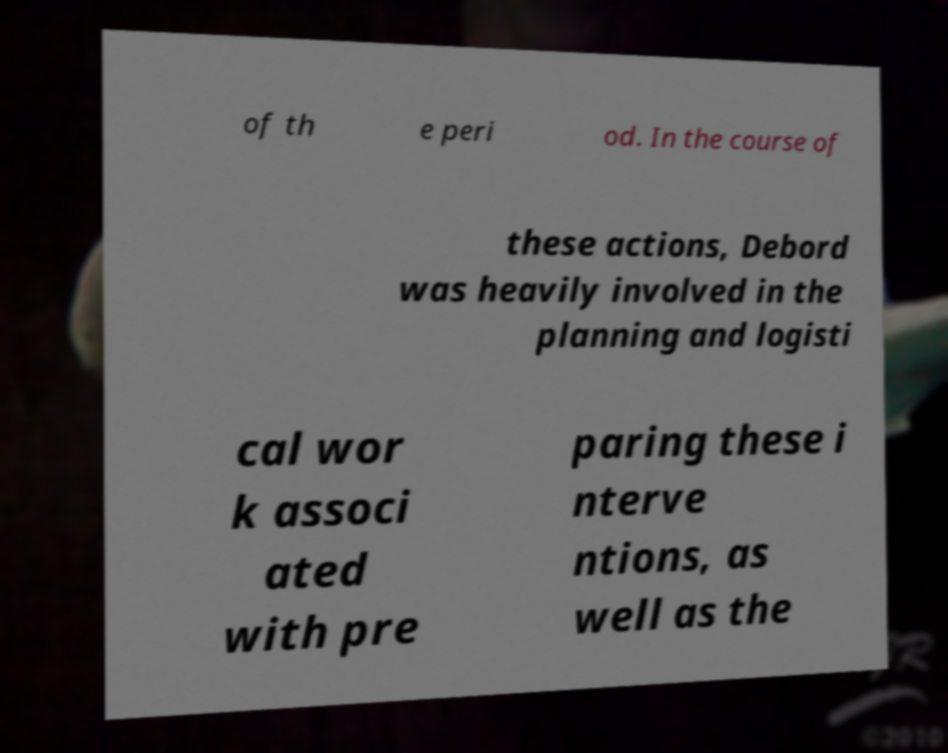Could you extract and type out the text from this image? of th e peri od. In the course of these actions, Debord was heavily involved in the planning and logisti cal wor k associ ated with pre paring these i nterve ntions, as well as the 